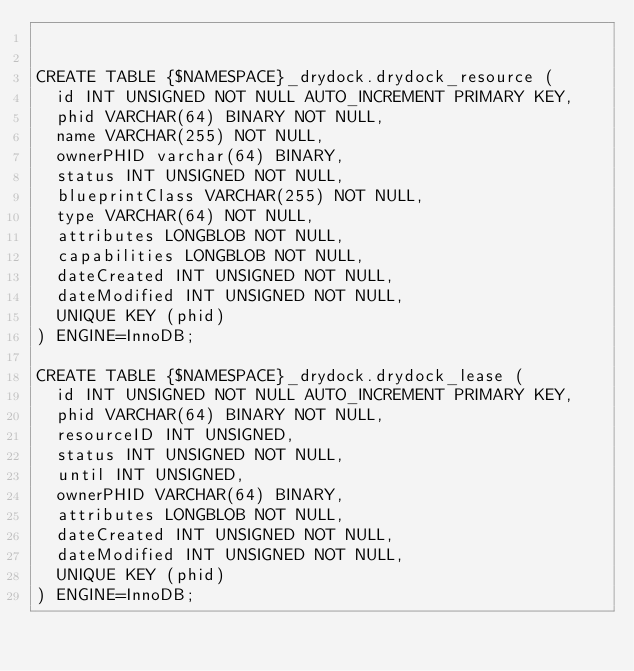Convert code to text. <code><loc_0><loc_0><loc_500><loc_500><_SQL_>

CREATE TABLE {$NAMESPACE}_drydock.drydock_resource (
  id INT UNSIGNED NOT NULL AUTO_INCREMENT PRIMARY KEY,
  phid VARCHAR(64) BINARY NOT NULL,
  name VARCHAR(255) NOT NULL,
  ownerPHID varchar(64) BINARY,
  status INT UNSIGNED NOT NULL,
  blueprintClass VARCHAR(255) NOT NULL,
  type VARCHAR(64) NOT NULL,
  attributes LONGBLOB NOT NULL,
  capabilities LONGBLOB NOT NULL,
  dateCreated INT UNSIGNED NOT NULL,
  dateModified INT UNSIGNED NOT NULL,
  UNIQUE KEY (phid)
) ENGINE=InnoDB;

CREATE TABLE {$NAMESPACE}_drydock.drydock_lease (
  id INT UNSIGNED NOT NULL AUTO_INCREMENT PRIMARY KEY,
  phid VARCHAR(64) BINARY NOT NULL,
  resourceID INT UNSIGNED,
  status INT UNSIGNED NOT NULL,
  until INT UNSIGNED,
  ownerPHID VARCHAR(64) BINARY,
  attributes LONGBLOB NOT NULL,
  dateCreated INT UNSIGNED NOT NULL,
  dateModified INT UNSIGNED NOT NULL,
  UNIQUE KEY (phid)
) ENGINE=InnoDB;
</code> 